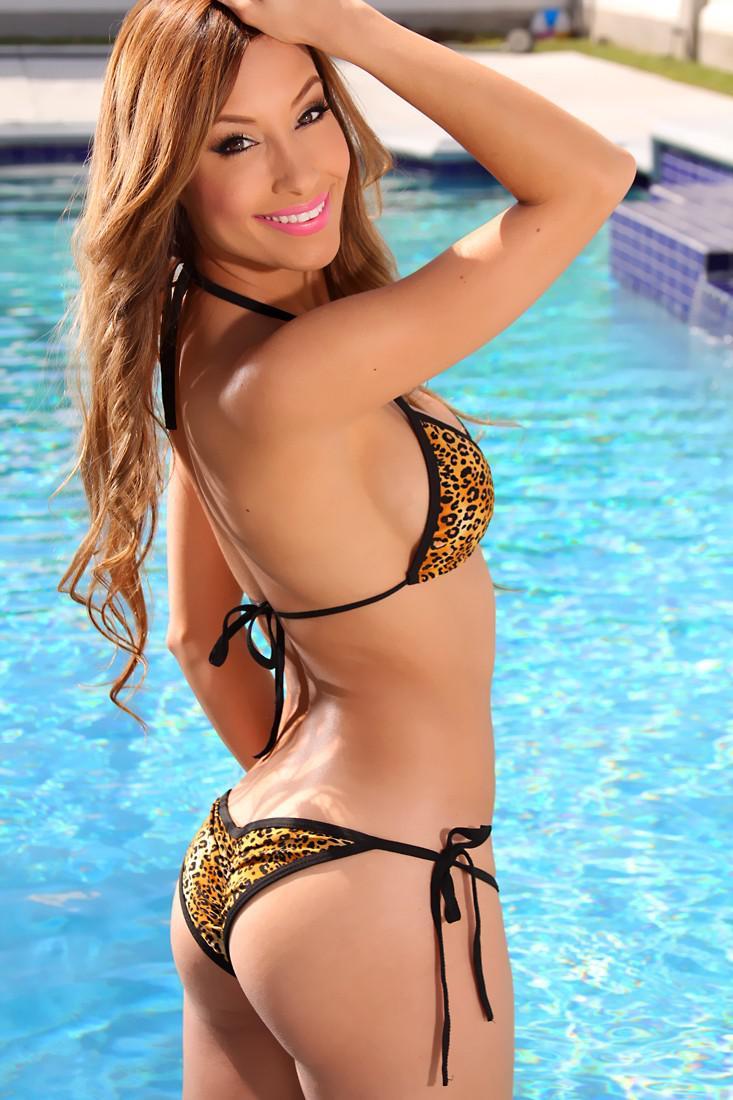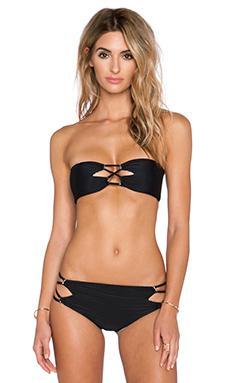The first image is the image on the left, the second image is the image on the right. Evaluate the accuracy of this statement regarding the images: "One of the images shows a woman near a swimming pool.". Is it true? Answer yes or no. Yes. The first image is the image on the left, the second image is the image on the right. Analyze the images presented: Is the assertion "All bikinis shown are solid black." valid? Answer yes or no. No. 